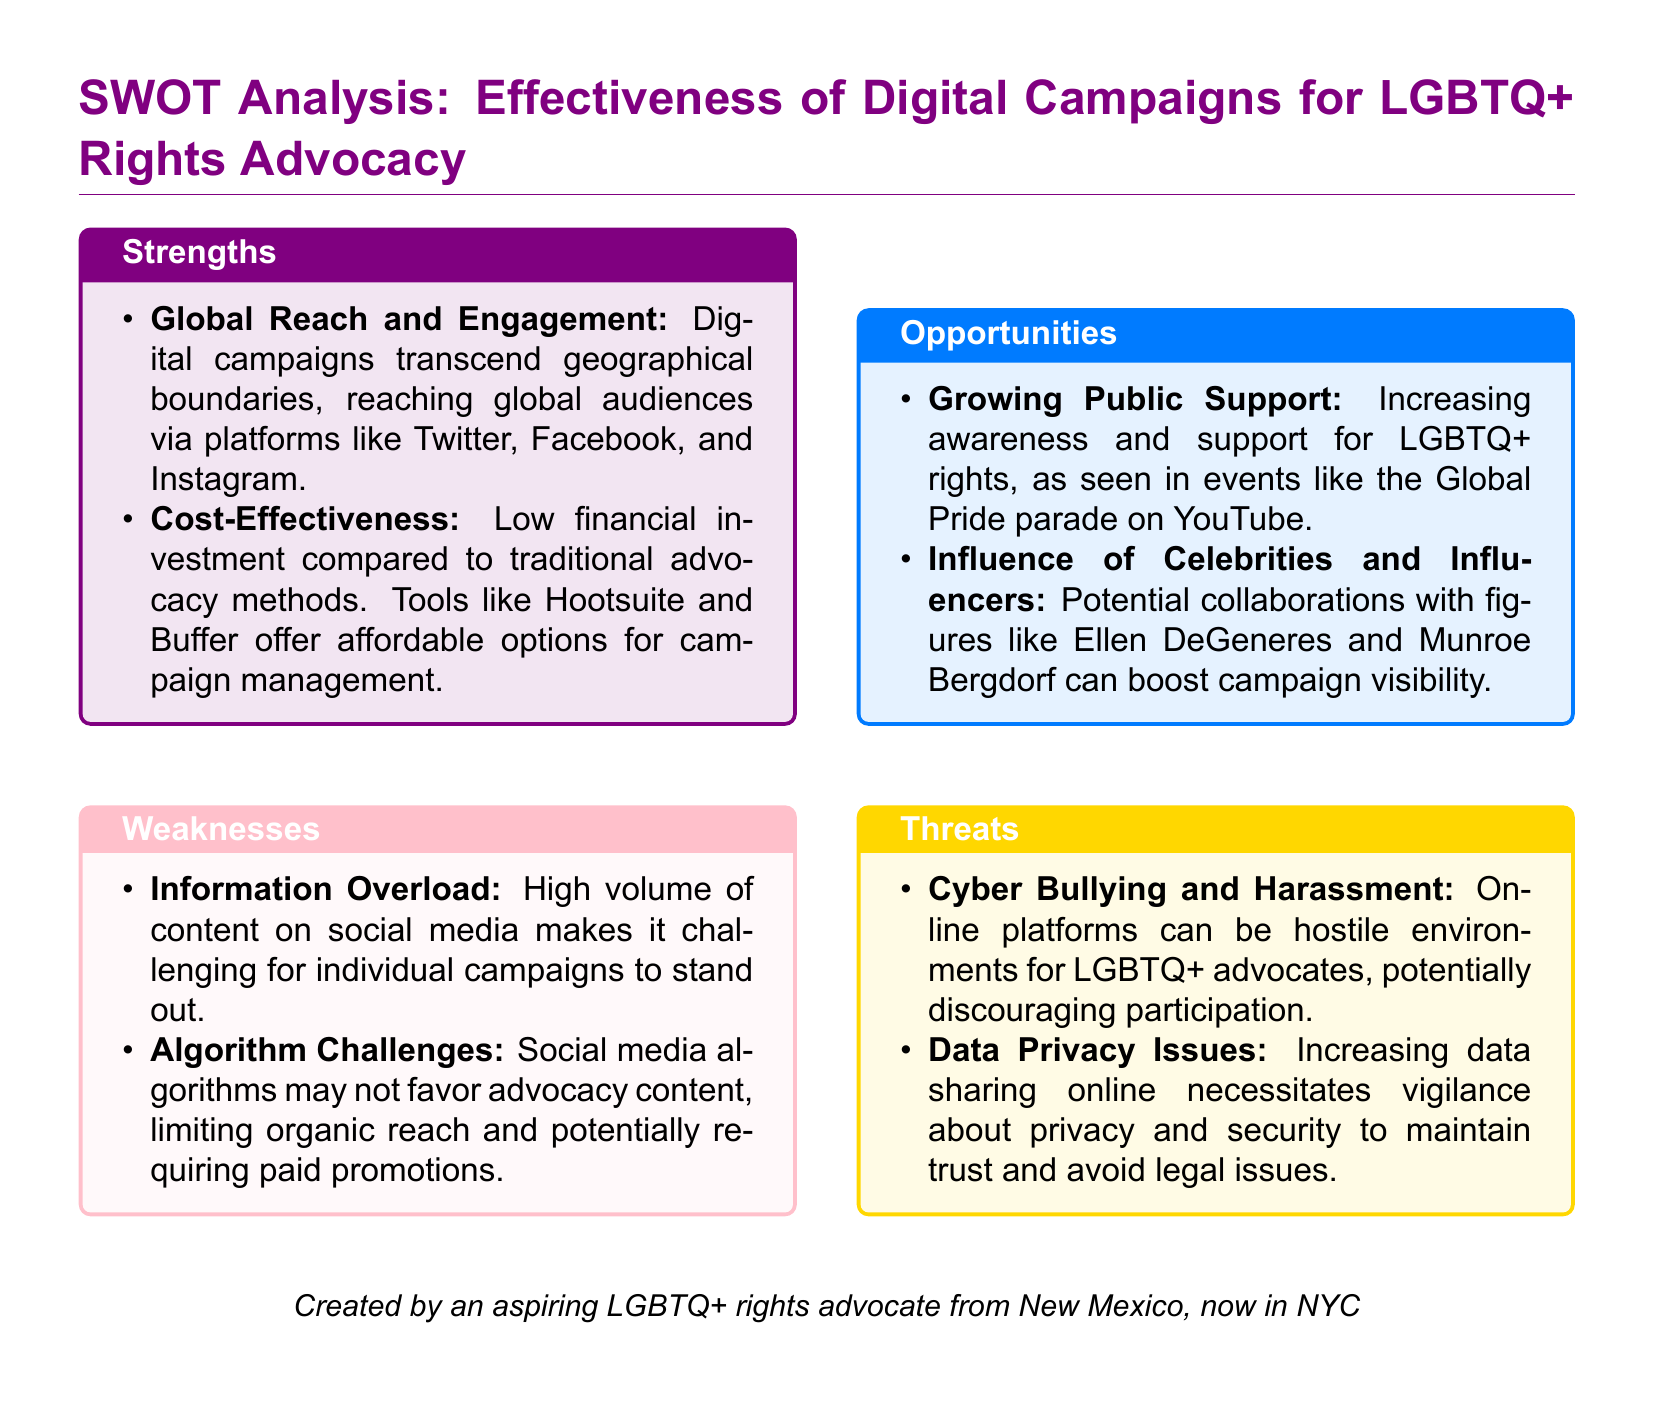What are two strengths of digital campaigns for LGBTQ+ rights advocacy? The document lists strengths such as global reach and cost-effectiveness.
Answer: Global Reach and Engagement; Cost-Effectiveness What is one weakness related to social media campaigns? The document identifies information overload as a weakness in digital campaigns.
Answer: Information Overload Which opportunity highlights growing public sentiment? The document mentions increasing awareness and support for LGBTQ+ rights as an opportunity.
Answer: Growing Public Support Who is an example of a celebrity that could influence campaigns? The SWOT analysis refers to Ellen DeGeneres as a potential influencer.
Answer: Ellen DeGeneres What threat is related to online environments for LGBTQ+ advocates? Cyber bullying and harassment is highlighted as a significant threat in the document.
Answer: Cyber Bullying and Harassment What is the color code for strengths in the SWOT analysis? The document specifies that the color for strengths is lgbtpurple.
Answer: lgbtpurple What tool is mentioned as a cost-effective option for campaign management? The document refers to tools like Hootsuite and Buffer for campaign management.
Answer: Hootsuite and Buffer How many main sections are presented in the SWOT analysis? The document includes four main sections: Strengths, Weaknesses, Opportunities, and Threats.
Answer: Four 